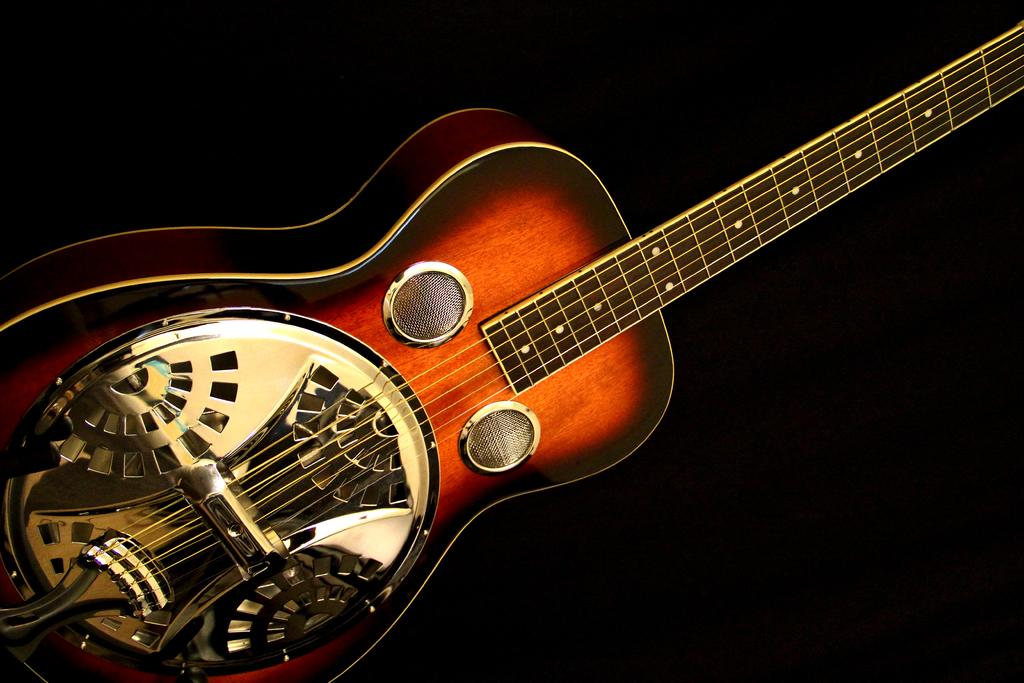What type of musical instrument is in the image? There is a golden brown guitar in the image. What can be observed about the color of the guitar? The guitar has a golden brown color. What is the color of the background in the image? The background of the image is dark. What type of quilt is draped over the guitar in the image? There is no quilt present in the image; it only features a guitar. What kind of cheese is visible on the guitar strings in the image? There is no cheese present in the image; it only features a guitar. 